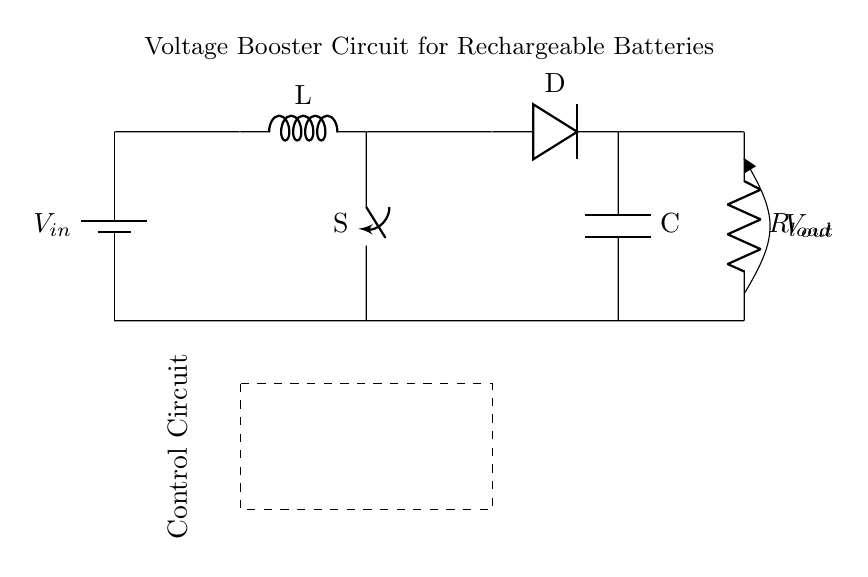What is the input voltage of this circuit? The input voltage is denoted by V-in, which is labeled on the battery component at the top of the circuit diagram.
Answer: V-in What type of component is used to boost the voltage? The circuit uses an inductor (L) as the key component for voltage boosting, as shown between the battery and the diode in the diagram.
Answer: Inductor What connects the control circuit to the rest of the circuit? The control circuit connects via short lines to the switch, which interacts with the inductor and supplies power, enabling control over the flow of electricity.
Answer: Short lines What does the diode do in this circuit? The diode allows current to flow in one direction only, preventing reverse current, which is critical for maintaining the desired output voltage to the load.
Answer: Prevents reverse current How does the switch affect the circuit? The switch acts as a controller that can open or close the circuit, thereby enabling or disabling the boosting process when toggled accordingly.
Answer: Controls current flow What is the function of the capacitor in this circuit? The capacitor smooths out the voltage fluctuations at the output, providing a more stable voltage to the load connected at R-load.
Answer: Smooths voltage fluctuations What is the load resistance connected to? The load resistance is connected to the output where V-out is indicated, showing the area where the boosted voltage is delivered to the load in the circuit.
Answer: R-load 